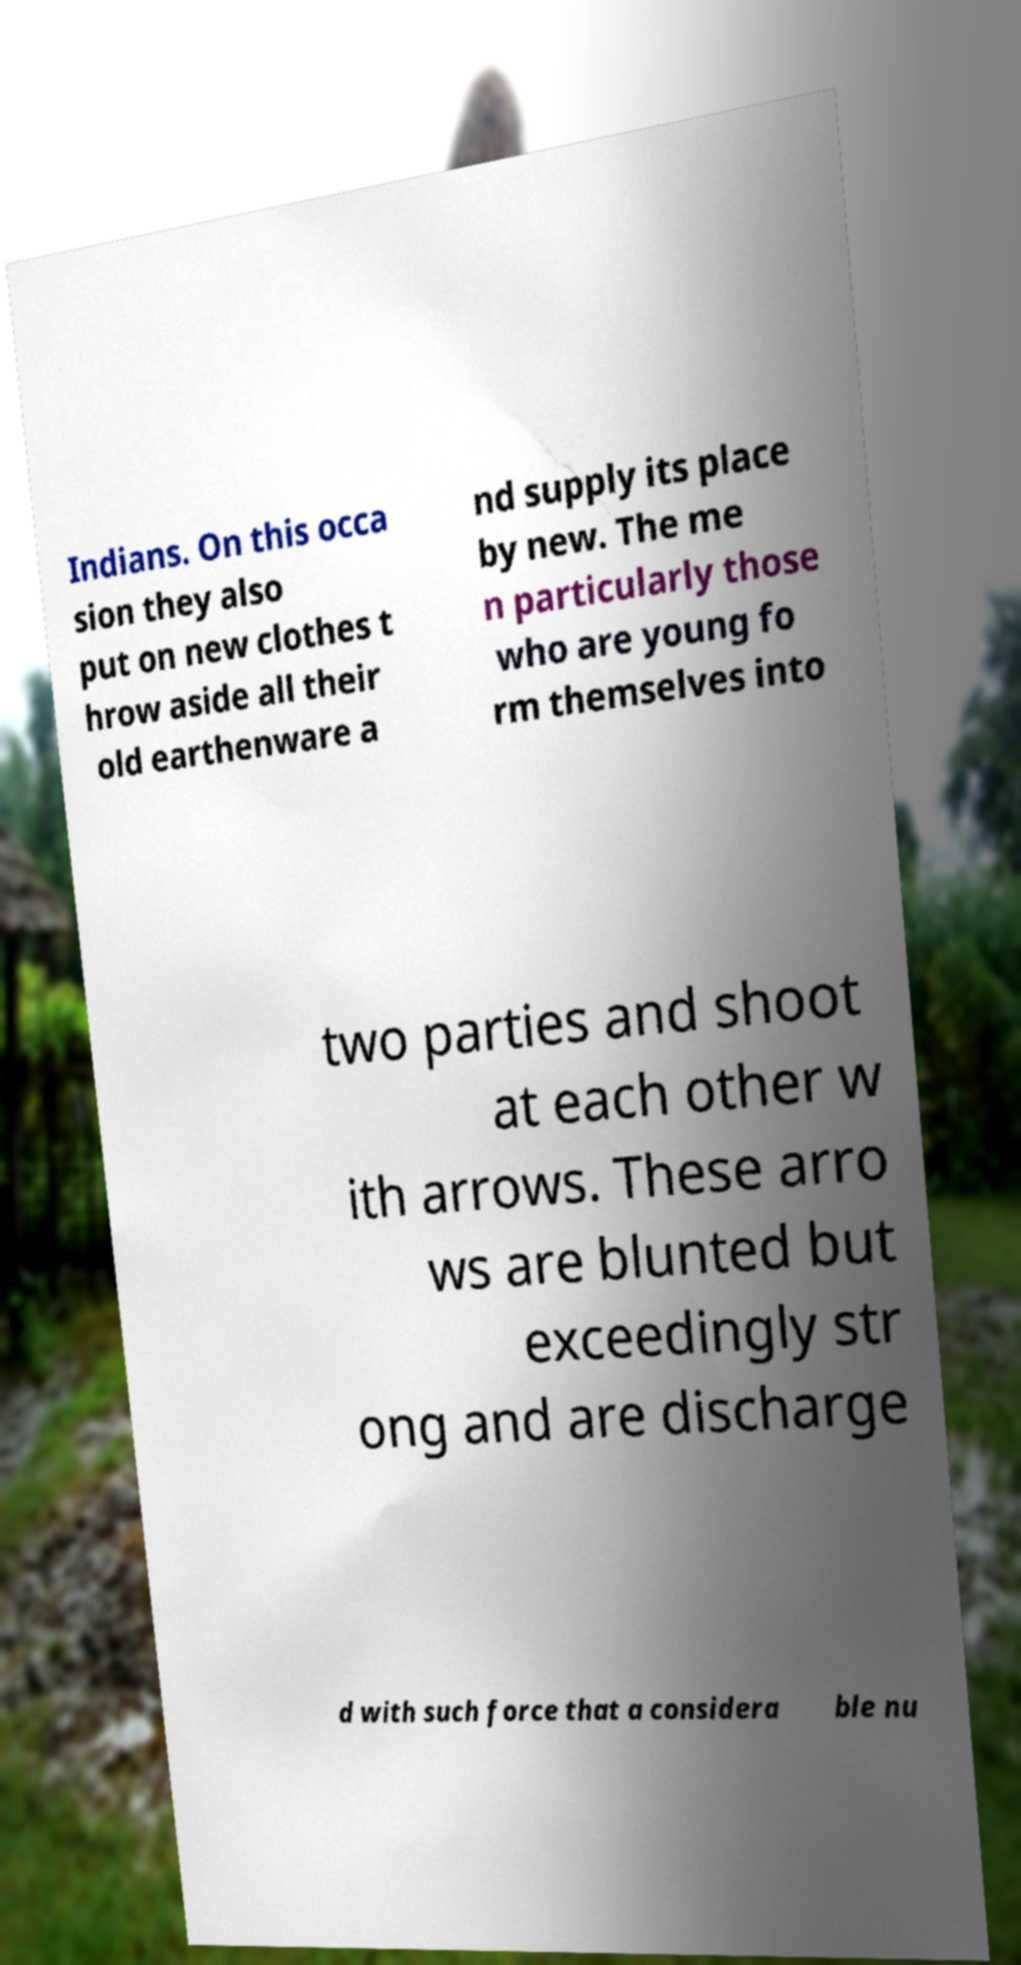There's text embedded in this image that I need extracted. Can you transcribe it verbatim? Indians. On this occa sion they also put on new clothes t hrow aside all their old earthenware a nd supply its place by new. The me n particularly those who are young fo rm themselves into two parties and shoot at each other w ith arrows. These arro ws are blunted but exceedingly str ong and are discharge d with such force that a considera ble nu 